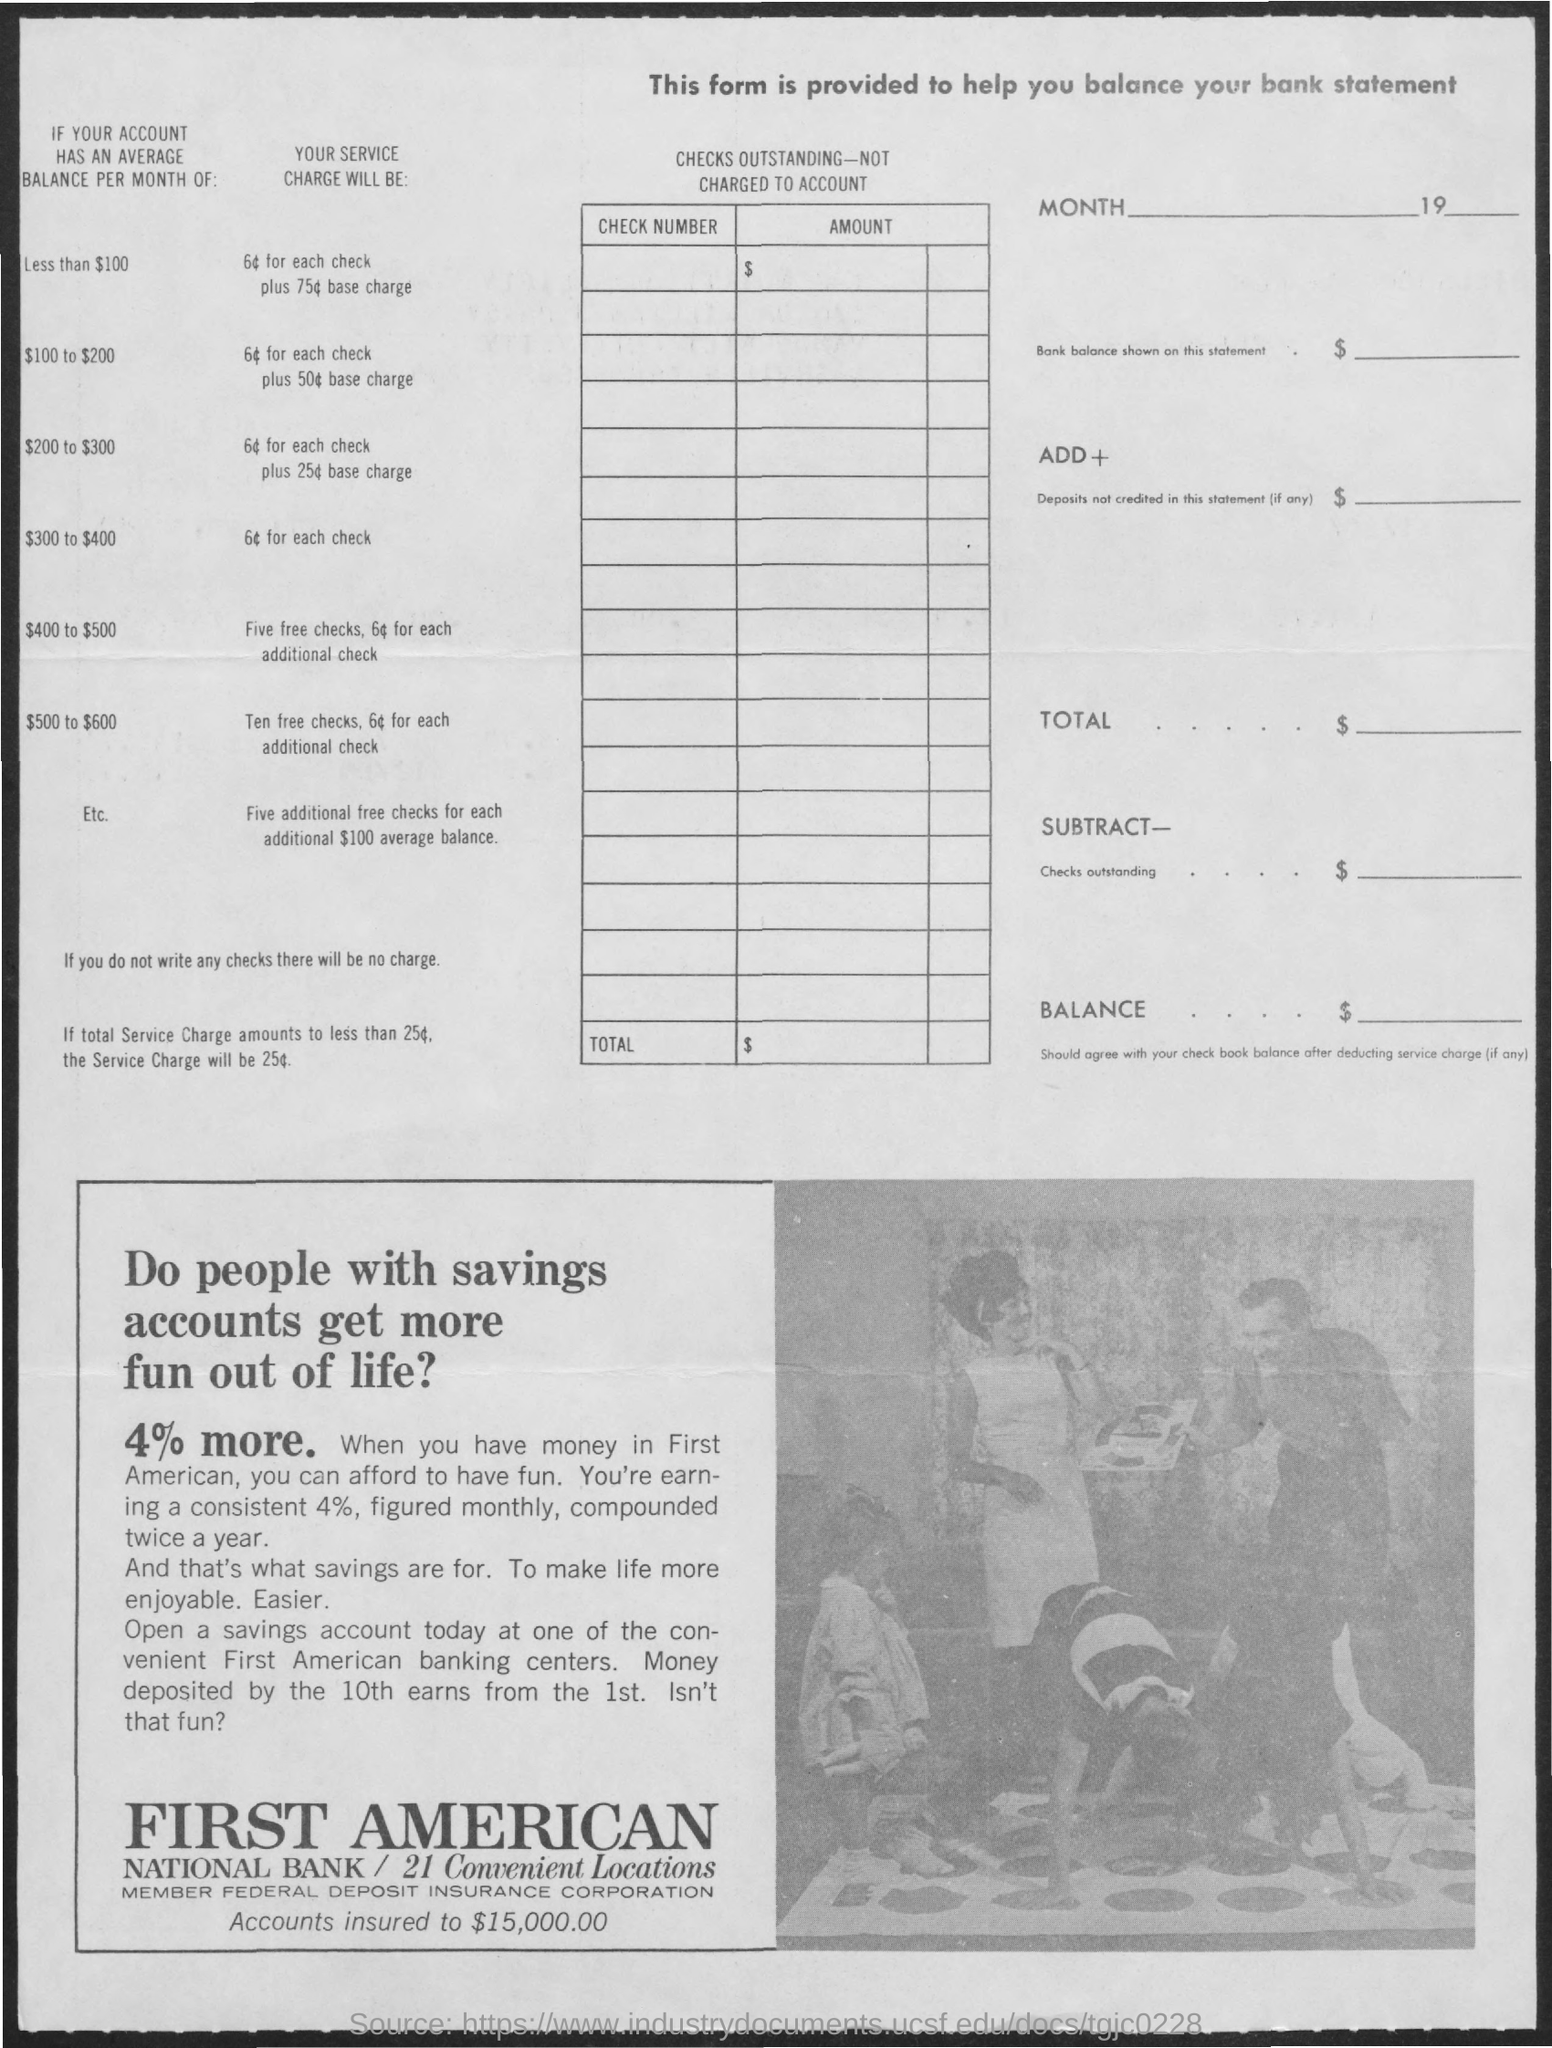What is the title of the first column of the table?
Provide a succinct answer. CHECK NUMBER. What is the title of the second column of the table?
Ensure brevity in your answer.  AMOUNT. 